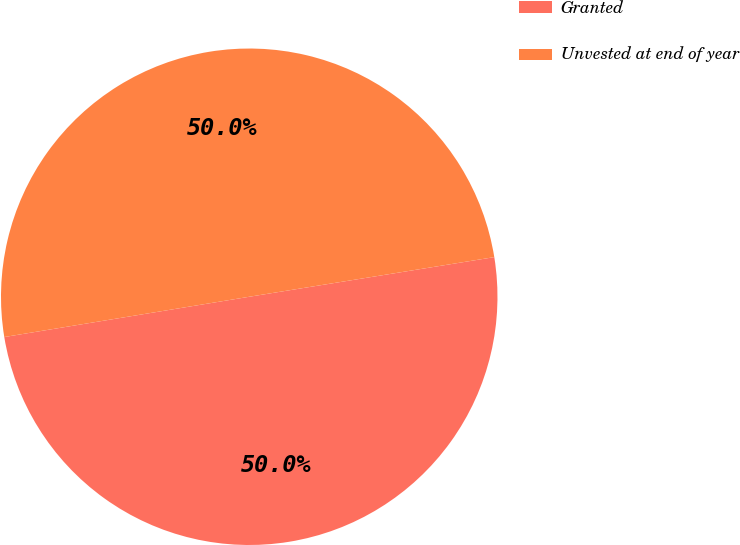Convert chart to OTSL. <chart><loc_0><loc_0><loc_500><loc_500><pie_chart><fcel>Granted<fcel>Unvested at end of year<nl><fcel>49.96%<fcel>50.04%<nl></chart> 